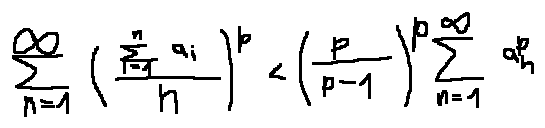Convert formula to latex. <formula><loc_0><loc_0><loc_500><loc_500>\sum \lim i t s _ { n = 1 } ^ { \infty } ( \frac { \sum \lim i t s _ { i = 1 } ^ { n } a _ { i } } { n } ) ^ { p } < ( \frac { p } { p - 1 } ) ^ { p } \sum \lim i t s _ { n = 1 } ^ { \infty } a _ { n } ^ { p }</formula> 